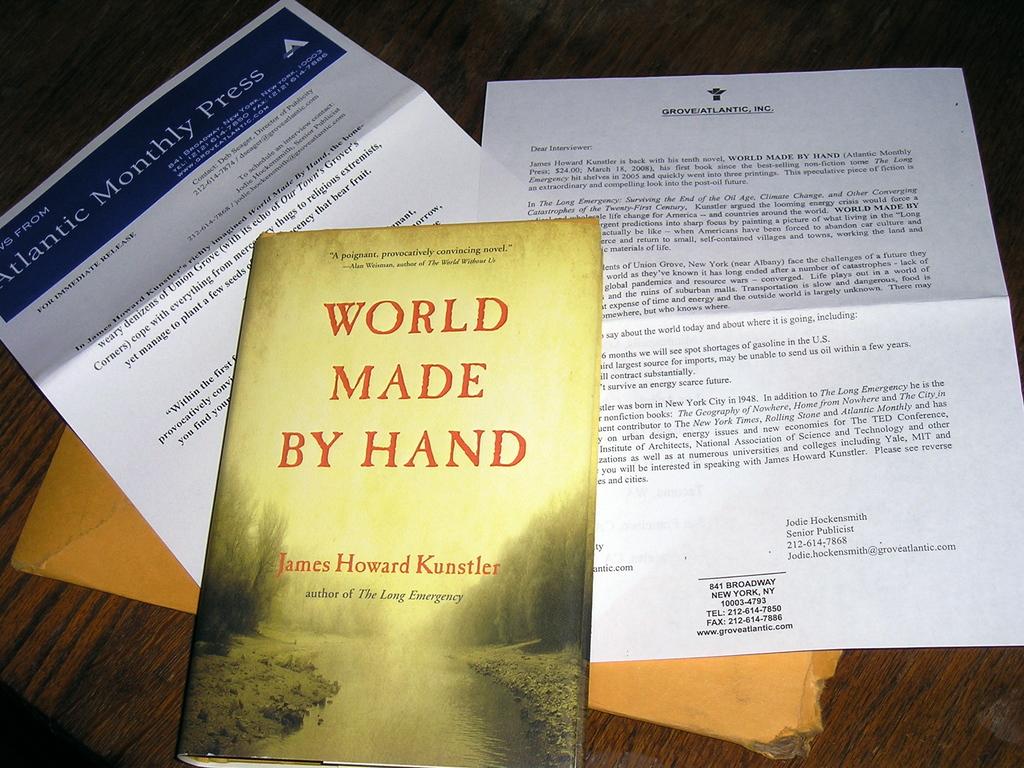Who wrote the book?
Your answer should be very brief. James howard kunstler. 